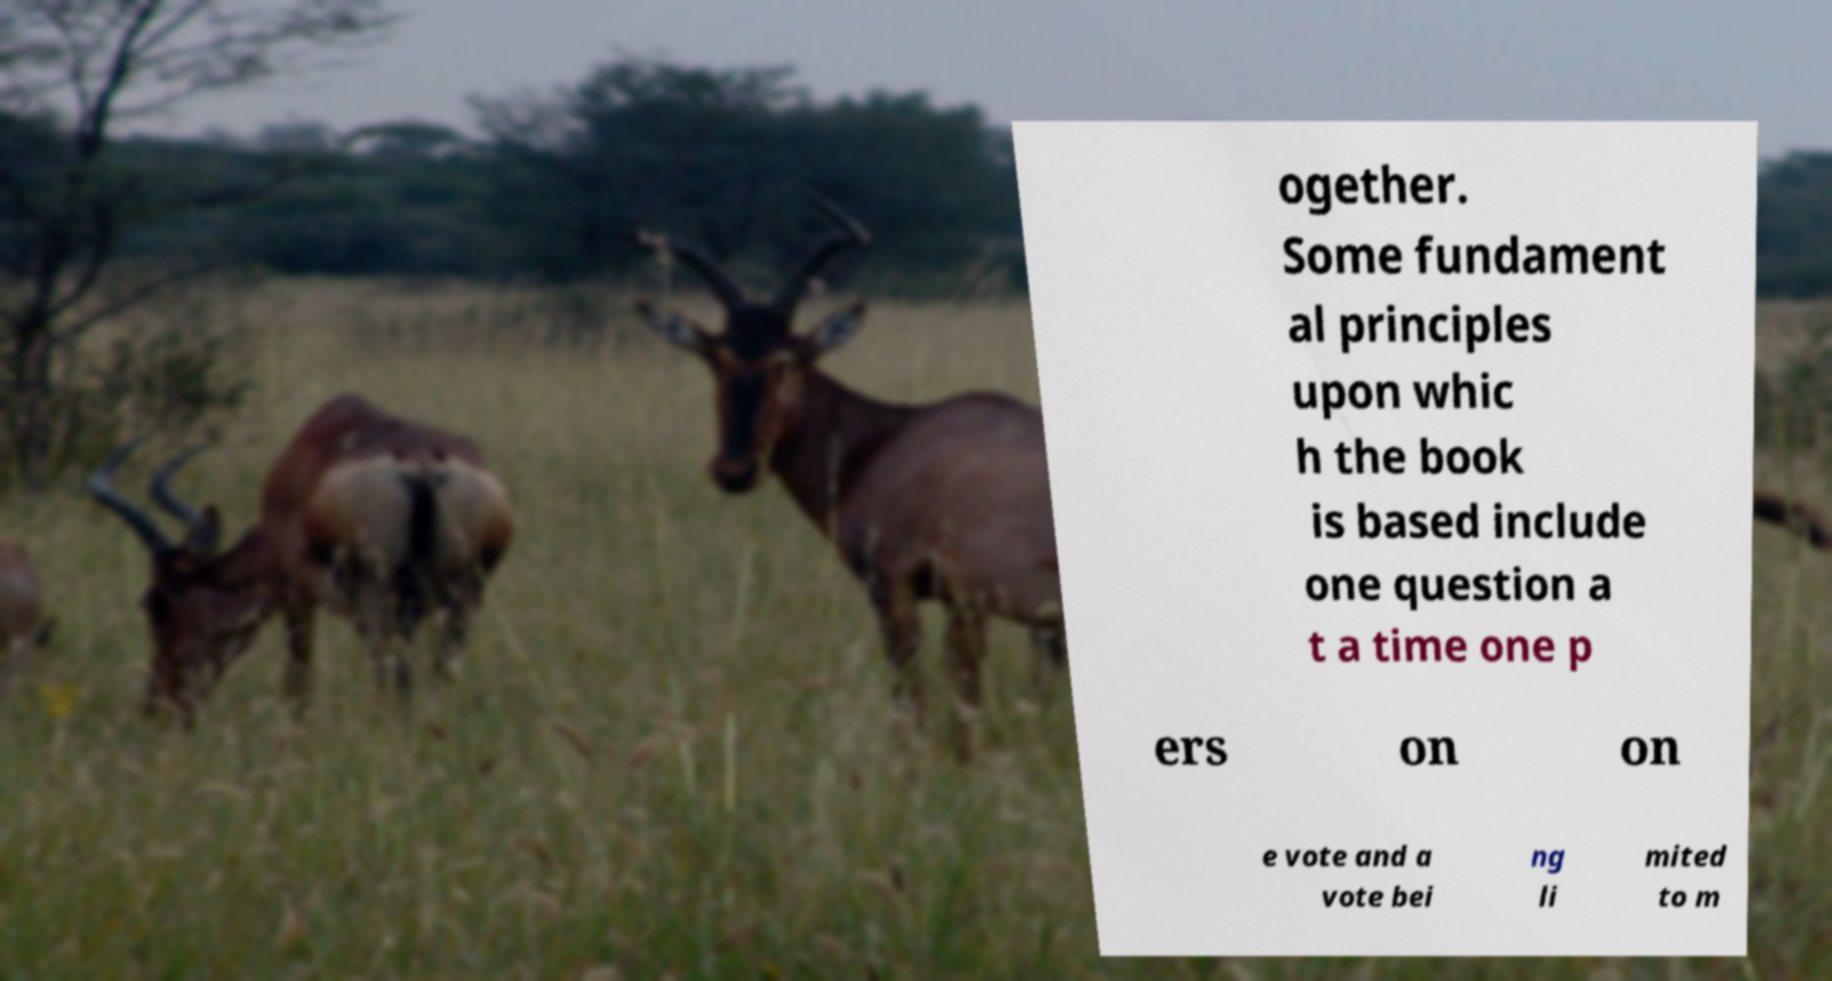Please read and relay the text visible in this image. What does it say? ogether. Some fundament al principles upon whic h the book is based include one question a t a time one p ers on on e vote and a vote bei ng li mited to m 